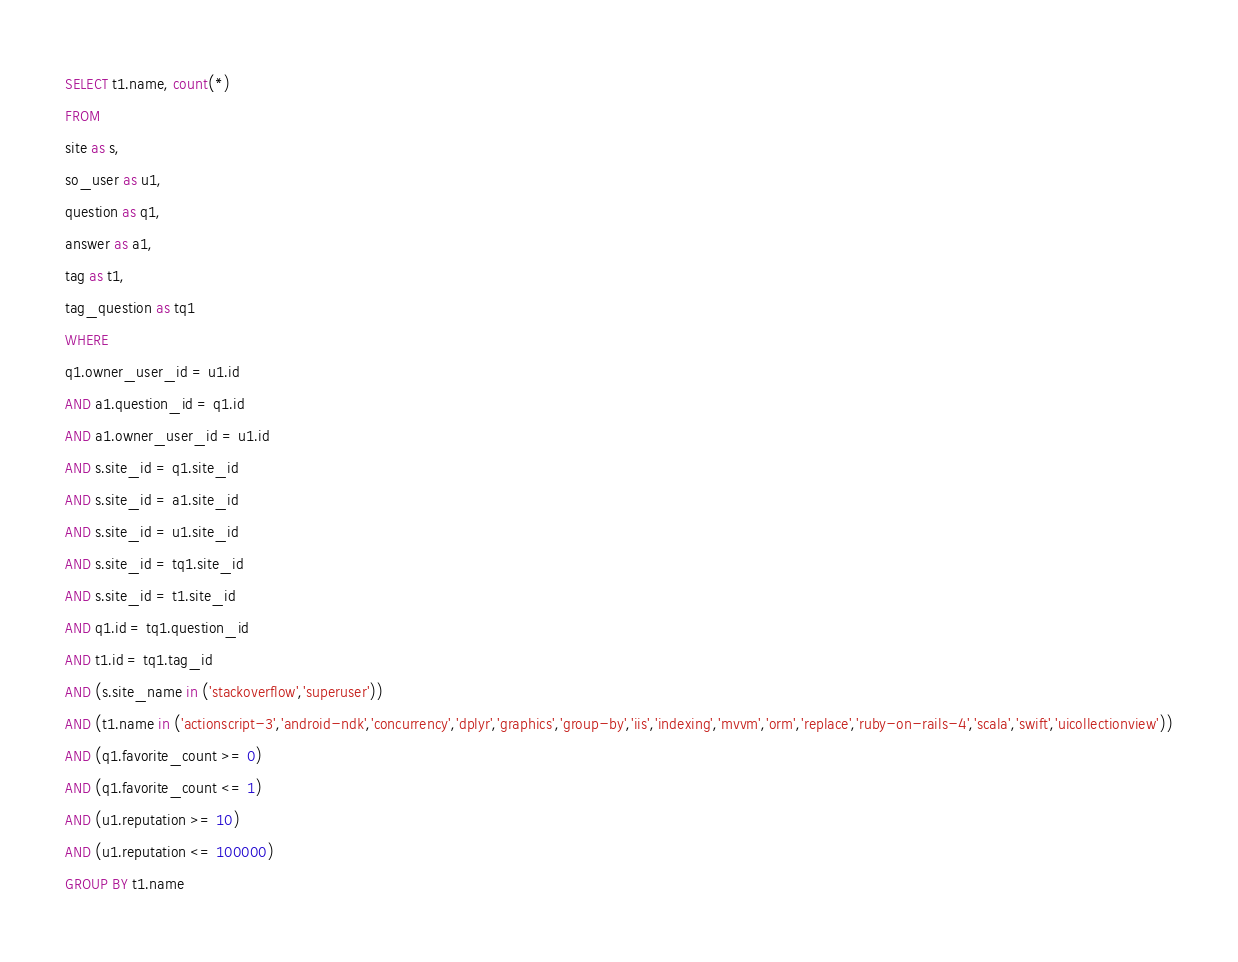<code> <loc_0><loc_0><loc_500><loc_500><_SQL_>SELECT t1.name, count(*)
FROM
site as s,
so_user as u1,
question as q1,
answer as a1,
tag as t1,
tag_question as tq1
WHERE
q1.owner_user_id = u1.id
AND a1.question_id = q1.id
AND a1.owner_user_id = u1.id
AND s.site_id = q1.site_id
AND s.site_id = a1.site_id
AND s.site_id = u1.site_id
AND s.site_id = tq1.site_id
AND s.site_id = t1.site_id
AND q1.id = tq1.question_id
AND t1.id = tq1.tag_id
AND (s.site_name in ('stackoverflow','superuser'))
AND (t1.name in ('actionscript-3','android-ndk','concurrency','dplyr','graphics','group-by','iis','indexing','mvvm','orm','replace','ruby-on-rails-4','scala','swift','uicollectionview'))
AND (q1.favorite_count >= 0)
AND (q1.favorite_count <= 1)
AND (u1.reputation >= 10)
AND (u1.reputation <= 100000)
GROUP BY t1.name</code> 